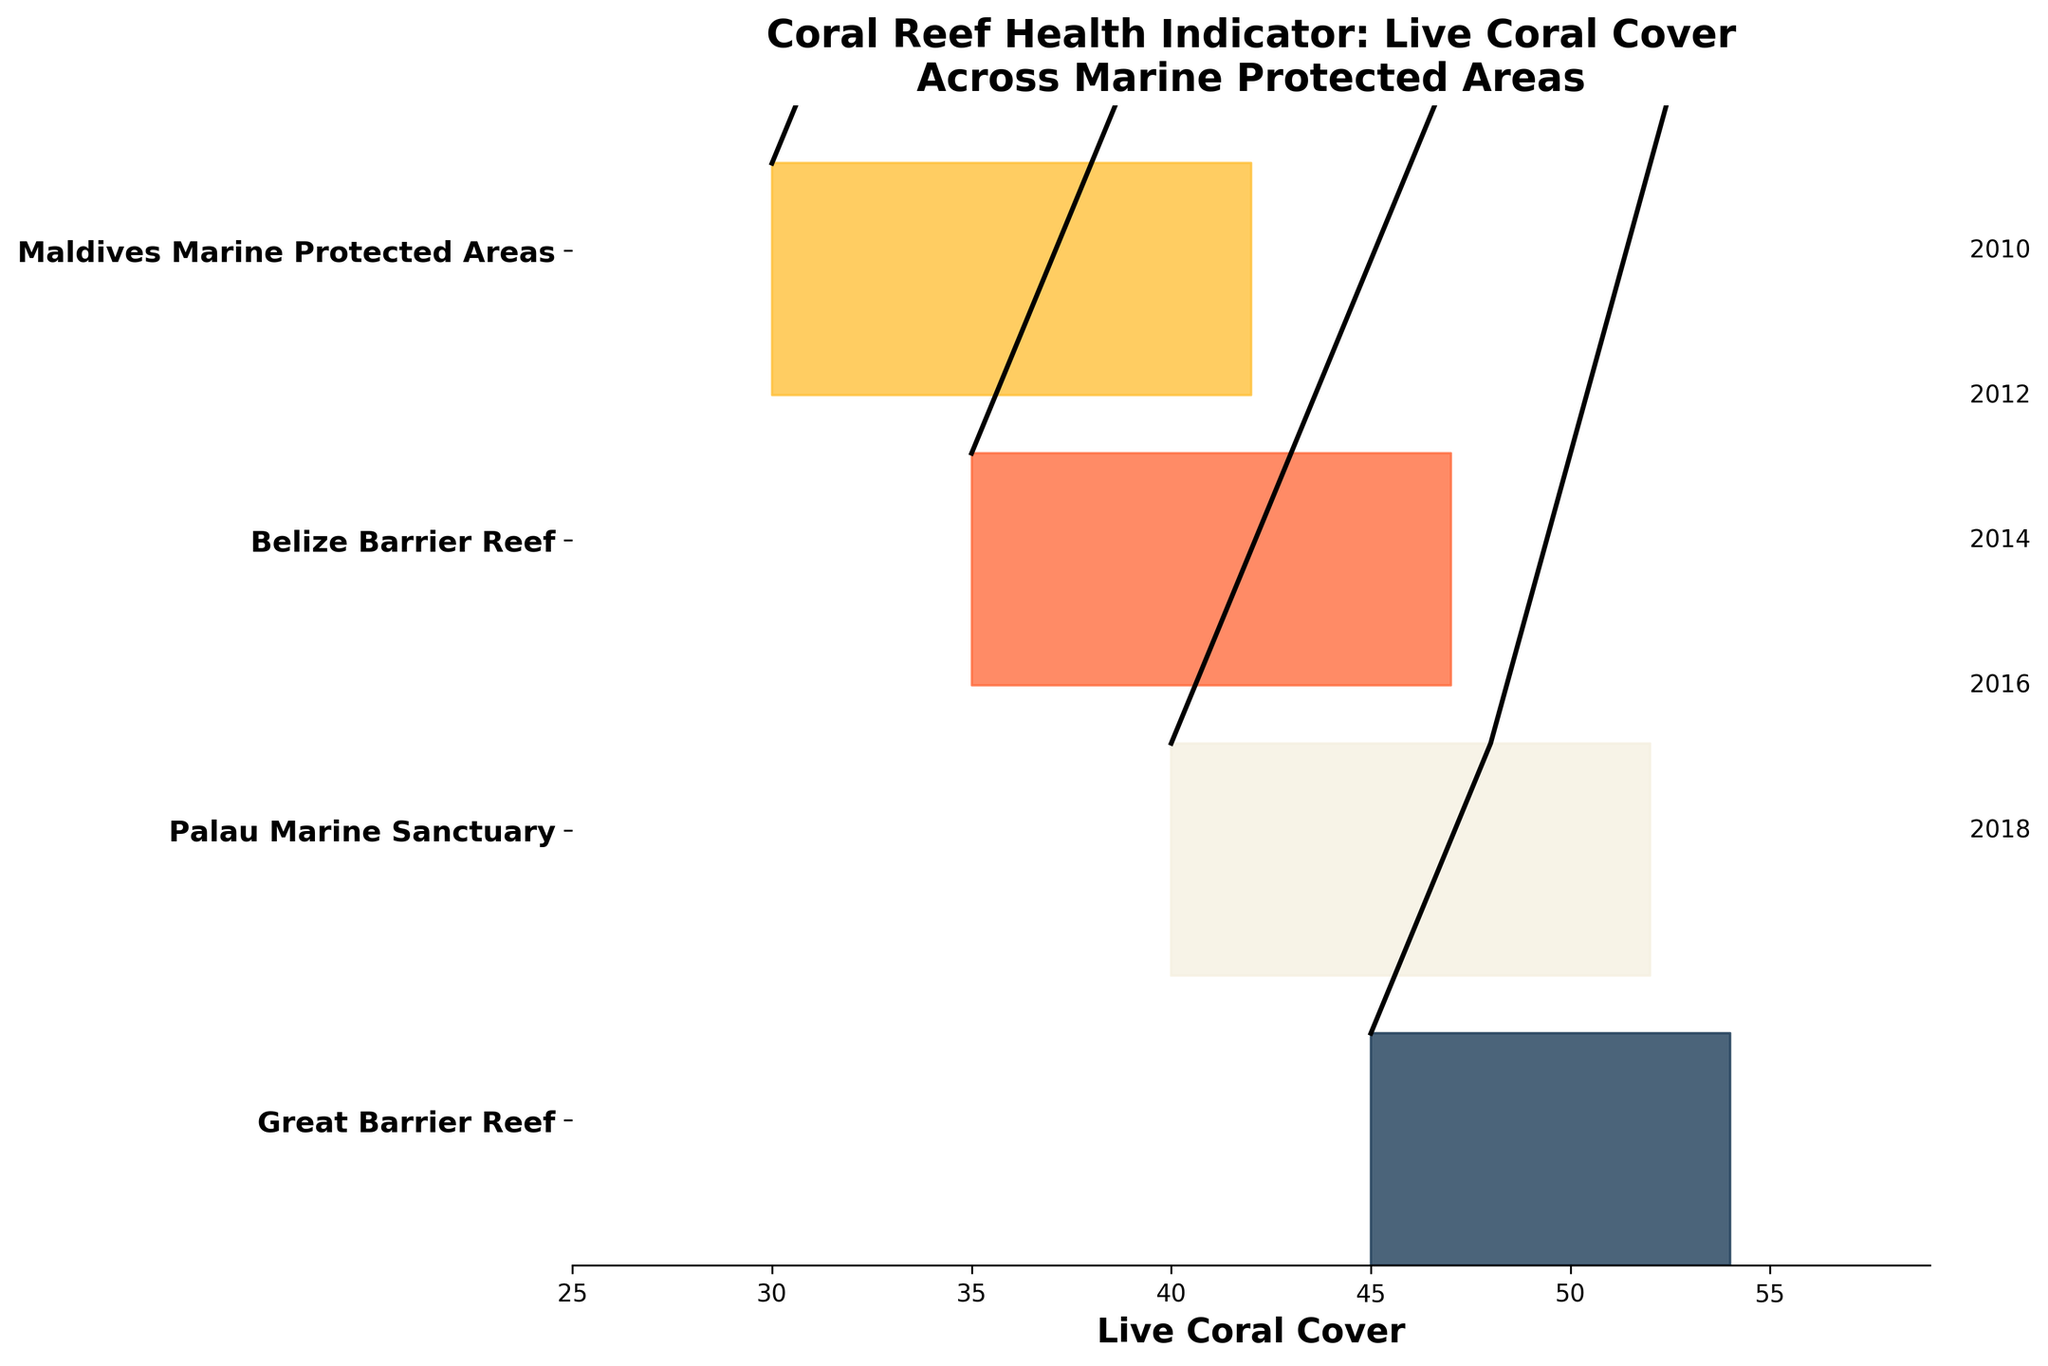What's the title of the plot? Look at the top of the figure where the title is usually placed.
Answer: Coral Reef Health Indicator: Live Coral Cover Across Marine Protected Areas What does the x-axis represent? Check the label at the bottom of the x-axis.
Answer: Live Coral Cover Which MPA has the highest Live Coral Cover in 2018? Identify which ridgeline corresponds to 2018 for each MPA and compare their values on the x-axis.
Answer: Great Barrier Reef How does the Live Coral Cover of Belize Barrier Reef change from 2010 to 2018? Trace the ridgeline for Belize Barrier Reef and note the points for years 2010 through 2018. Observe the changes in values.
Answer: It increases from 35 in 2010 to 47 in 2018 Which MPA shows the steepest increase in Live Coral Cover over time? Compare the slopes of the ridgelines for each MPA over the years. The MPA with the steepest slope shows the steepest increase.
Answer: Maldives Marine Protected Areas Is there a downward trend in Live Coral Cover for any MPA? Check if any MPA ridgeline shows a decreasing pattern in values from 2010 to 2018.
Answer: No What is the difference in Live Coral Cover between the Great Barrier Reef and Palau Marine Sanctuary in 2014? Locate the 2014 values for both MPAs and subtract the smaller from the larger.
Answer: 4 (50 - 46) How does the Live Coral Cover of the Maldives Marine Protected Areas in 2016 compare to that of the Great Barrier Reef in 2010? Check the ridgelines for the Maldives Marine Protected Areas in 2016 and the Great Barrier Reef in 2010, and compare their values.
Answer: Higher by 9 (39 compared to 30) Which MPA had the lowest Live Coral Cover in 2010? Identify the starting point for the ridgelines for each MPA in 2010 and compare the values.
Answer: Maldives Marine Protected Areas By how much did the Live Coral Cover increase for the Great Barrier Reef from 2010 to 2014? Locate the values for the Great Barrier Reef in 2010 and 2014, and compute the difference.
Answer: 5 (50 - 45) 